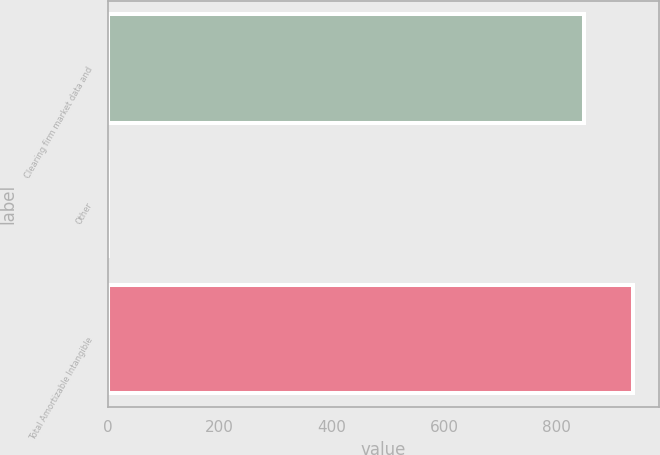<chart> <loc_0><loc_0><loc_500><loc_500><bar_chart><fcel>Clearing firm market data and<fcel>Other<fcel>Total Amortizable Intangible<nl><fcel>849.2<fcel>1<fcel>936.98<nl></chart> 